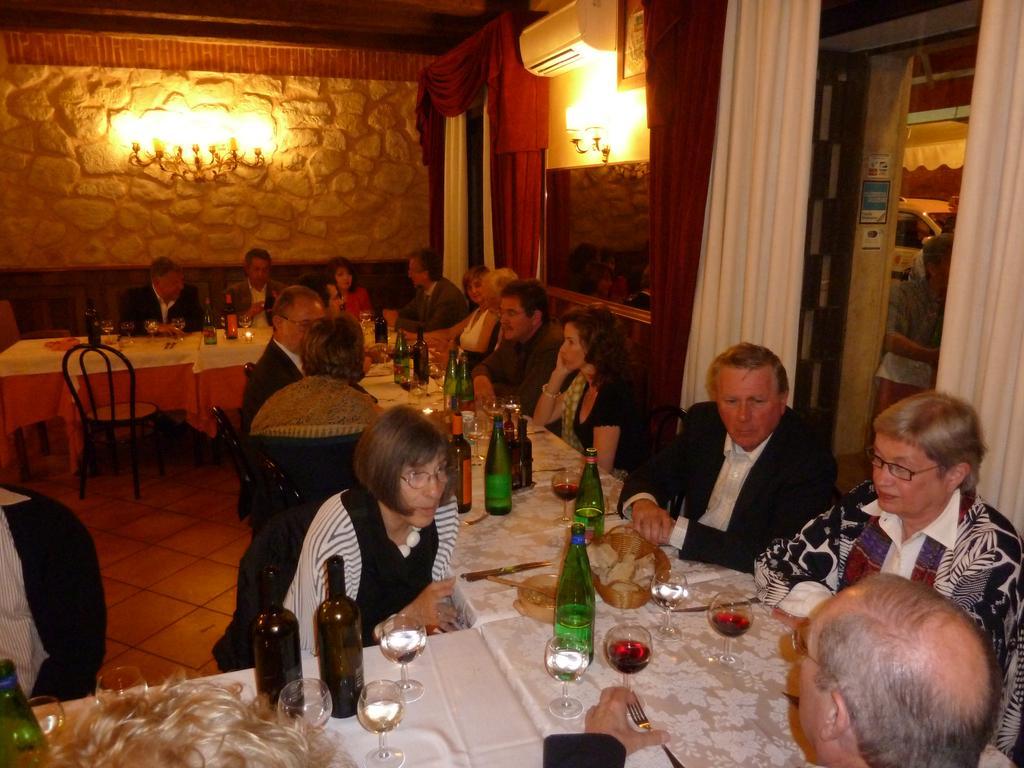Describe this image in one or two sentences. There are few people sitting on the chair at the table. On the table there are wine bottles,spoons,forks. In the background there is a wall,lights,curtains,windows and AC. 